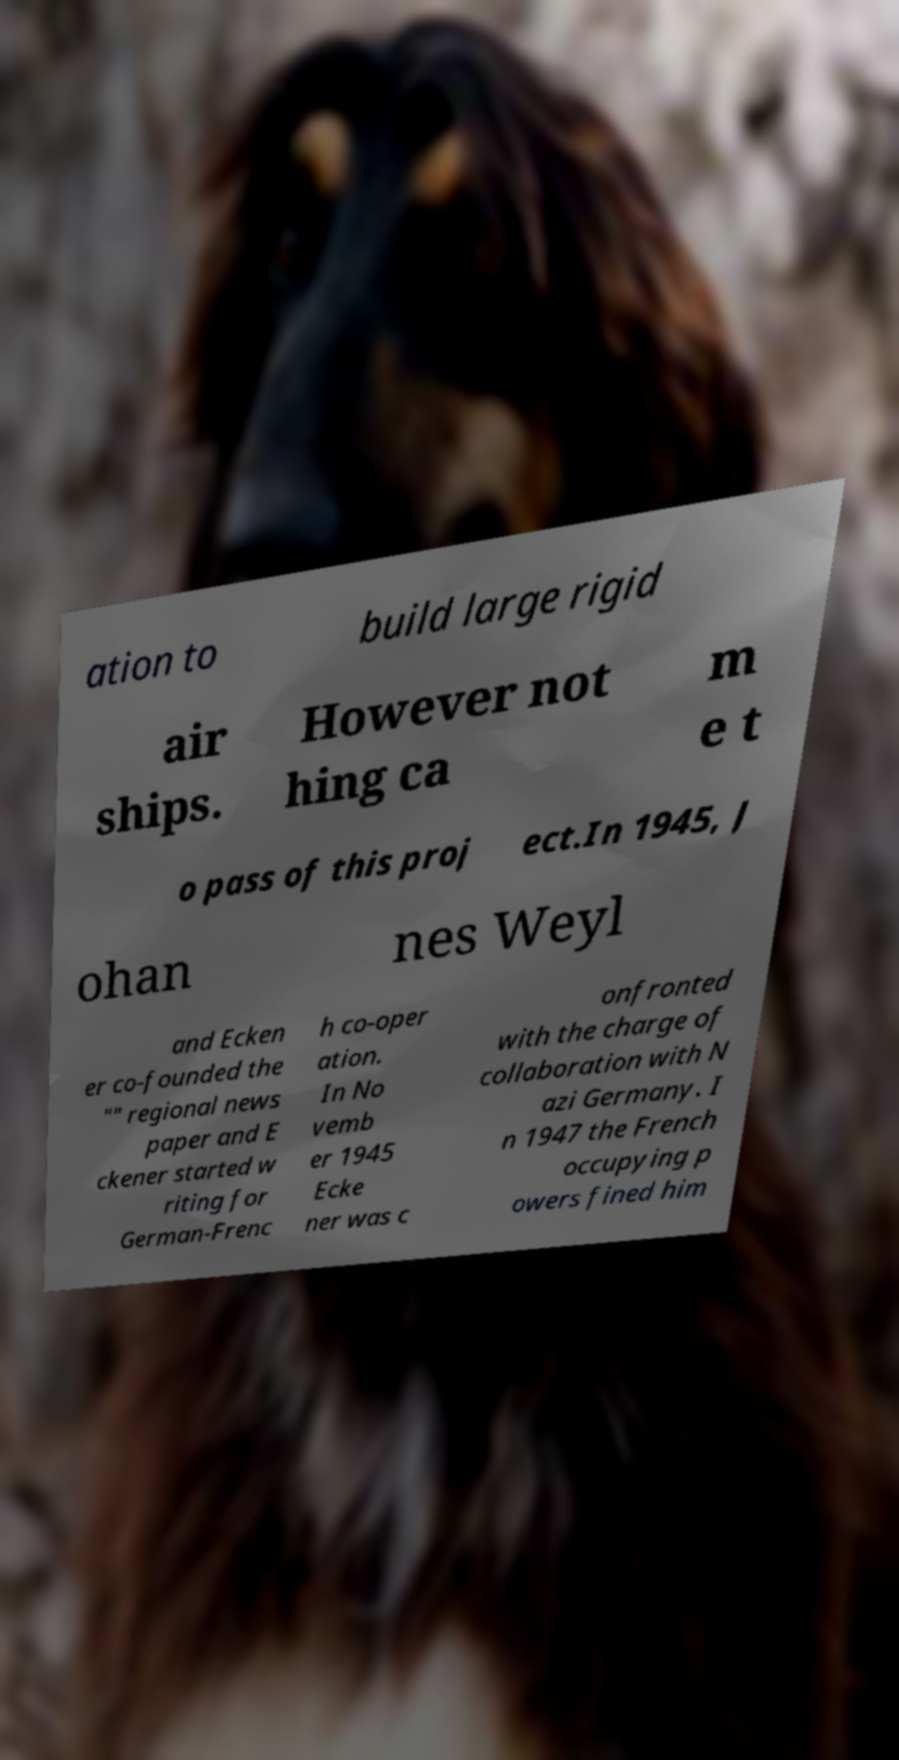Can you accurately transcribe the text from the provided image for me? ation to build large rigid air ships. However not hing ca m e t o pass of this proj ect.In 1945, J ohan nes Weyl and Ecken er co-founded the "" regional news paper and E ckener started w riting for German-Frenc h co-oper ation. In No vemb er 1945 Ecke ner was c onfronted with the charge of collaboration with N azi Germany. I n 1947 the French occupying p owers fined him 